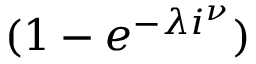Convert formula to latex. <formula><loc_0><loc_0><loc_500><loc_500>( 1 - e ^ { - \lambda i ^ { \nu } } )</formula> 